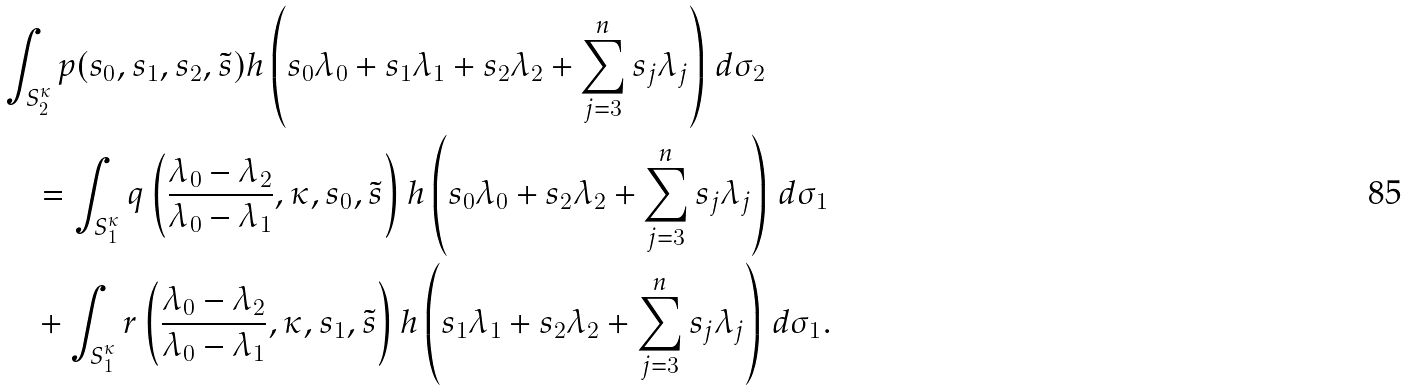<formula> <loc_0><loc_0><loc_500><loc_500>& \int _ { S _ { 2 } ^ { \kappa } } p ( s _ { 0 } , s _ { 1 } , s _ { 2 } , \tilde { s } ) h \left ( s _ { 0 } \lambda _ { 0 } + s _ { 1 } \lambda _ { 1 } + s _ { 2 } \lambda _ { 2 } + \sum _ { j = 3 } ^ { n } s _ { j } \lambda _ { j } \right ) \, d \sigma _ { 2 } \\ & \quad = \int _ { S _ { 1 } ^ { \kappa } } q \left ( \frac { \lambda _ { 0 } - \lambda _ { 2 } } { \lambda _ { 0 } - \lambda _ { 1 } } , \kappa , s _ { 0 } , \tilde { s } \right ) h \left ( s _ { 0 } \lambda _ { 0 } + s _ { 2 } \lambda _ { 2 } + \sum _ { j = 3 } ^ { n } s _ { j } \lambda _ { j } \right ) \, d \sigma _ { 1 } \\ & \quad + \int _ { S _ { 1 } ^ { \kappa } } r \left ( \frac { \lambda _ { 0 } - \lambda _ { 2 } } { \lambda _ { 0 } - \lambda _ { 1 } } , \kappa , s _ { 1 } , \tilde { s } \right ) h \left ( s _ { 1 } \lambda _ { 1 } + s _ { 2 } \lambda _ { 2 } + \sum _ { j = 3 } ^ { n } s _ { j } \lambda _ { j } \right ) \, d \sigma _ { 1 } .</formula> 